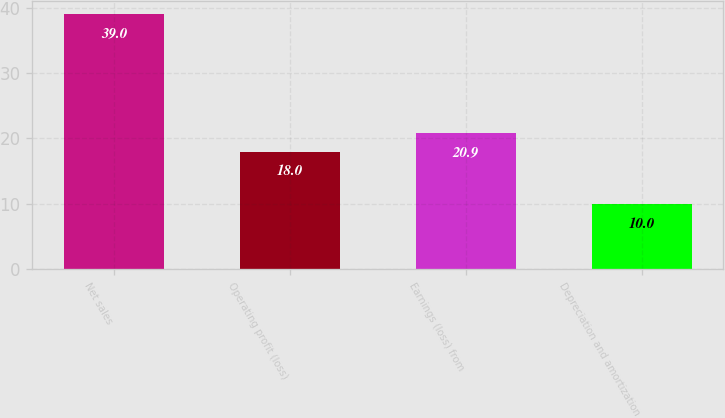Convert chart. <chart><loc_0><loc_0><loc_500><loc_500><bar_chart><fcel>Net sales<fcel>Operating profit (loss)<fcel>Earnings (loss) from<fcel>Depreciation and amortization<nl><fcel>39<fcel>18<fcel>20.9<fcel>10<nl></chart> 